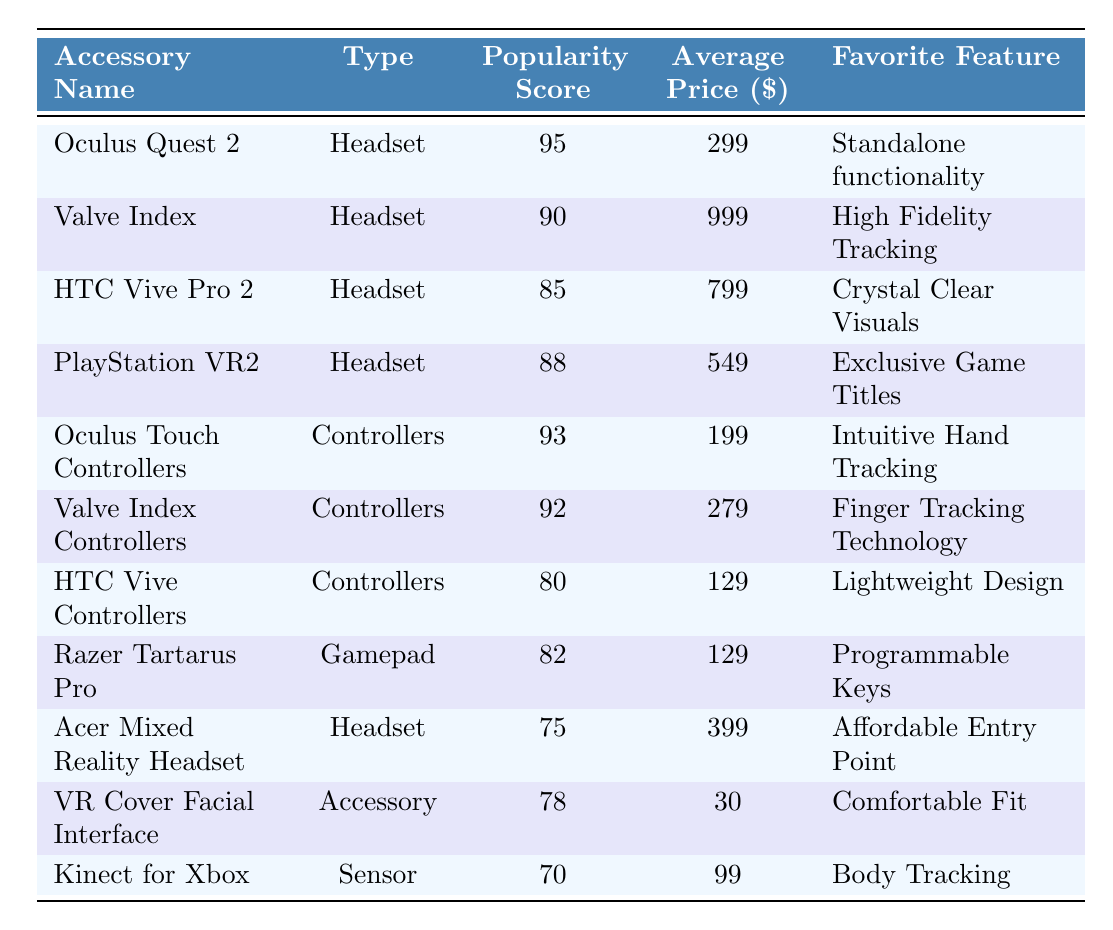What is the most popular VR headset according to the table? The table indicates that the "Oculus Quest 2" has the highest Popularity Score of 95 compared to other headsets listed.
Answer: Oculus Quest 2 Which accessory has the lowest popularity score? Referring to the table, the "Kinect for Xbox" has the lowest Popularity Score of 70 among all listed accessories.
Answer: Kinect for Xbox What is the average price of the controllers? The average price can be calculated by summing the prices of the controllers: 199 (Oculus Touch) + 279 (Valve Index) + 129 (HTC Vive) = 607, then dividing by the number of controllers (3): 607 / 3 = 202.33.
Answer: 202.33 Is the average price of the HTC Vive Pro 2 more than $800? The average price of the HTC Vive Pro 2 is $799, which is not more than $800.
Answer: No Which accessory has the favorite feature "Exclusive Game Titles"? The "PlayStation VR2" is the accessory listed with the favorite feature of "Exclusive Game Titles".
Answer: PlayStation VR2 How many accessories have a popularity score greater than 90? Four accessories have a popularity score greater than 90: Oculus Quest 2, Oculus Touch Controllers, Valve Index, and Valve Index Controllers.
Answer: 4 What’s the difference in popularity score between the Oculus Quest 2 and the HTC Vive Pro 2? The difference in popularity scores is calculated as follows: 95 (Oculus Quest 2) - 85 (HTC Vive Pro 2) = 10.
Answer: 10 Which accessory has the highest streamer adoption rate? According to the table, the "Oculus Quest 2" has the highest Streamer Adoption Rate of 85%.
Answer: Oculus Quest 2 Are there any accessories priced below $100? Yes, the "VR Cover Facial Interface" is priced at $30, which is below $100.
Answer: Yes What is the total popularity score of all the headsets combined? The combined popularity score is calculated by adding the scores of the headsets: 95 (Oculus Quest 2) + 90 (Valve Index) + 85 (HTC Vive Pro 2) + 88 (PlayStation VR2) + 75 (Acer Mixed Reality Headset) = 433.
Answer: 433 